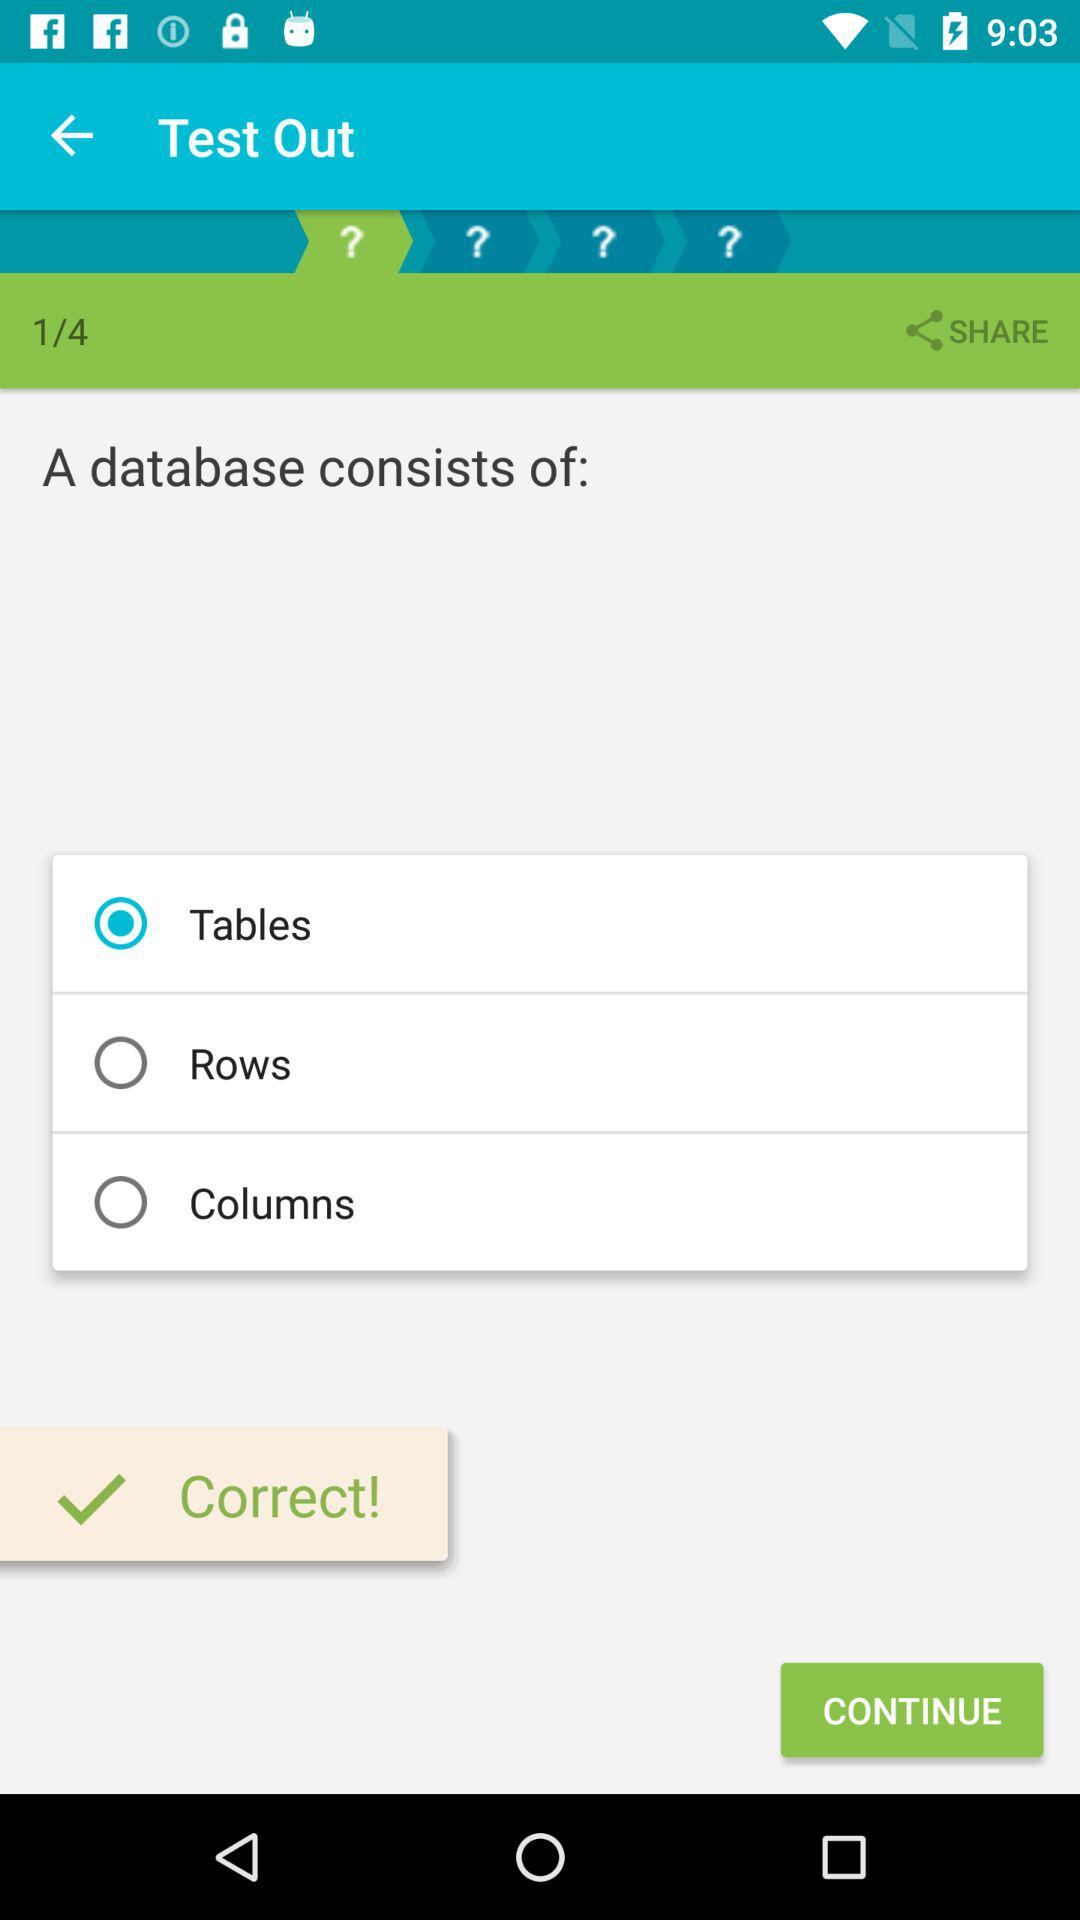Is the attempted question correct or not? The attempted question is correct. 